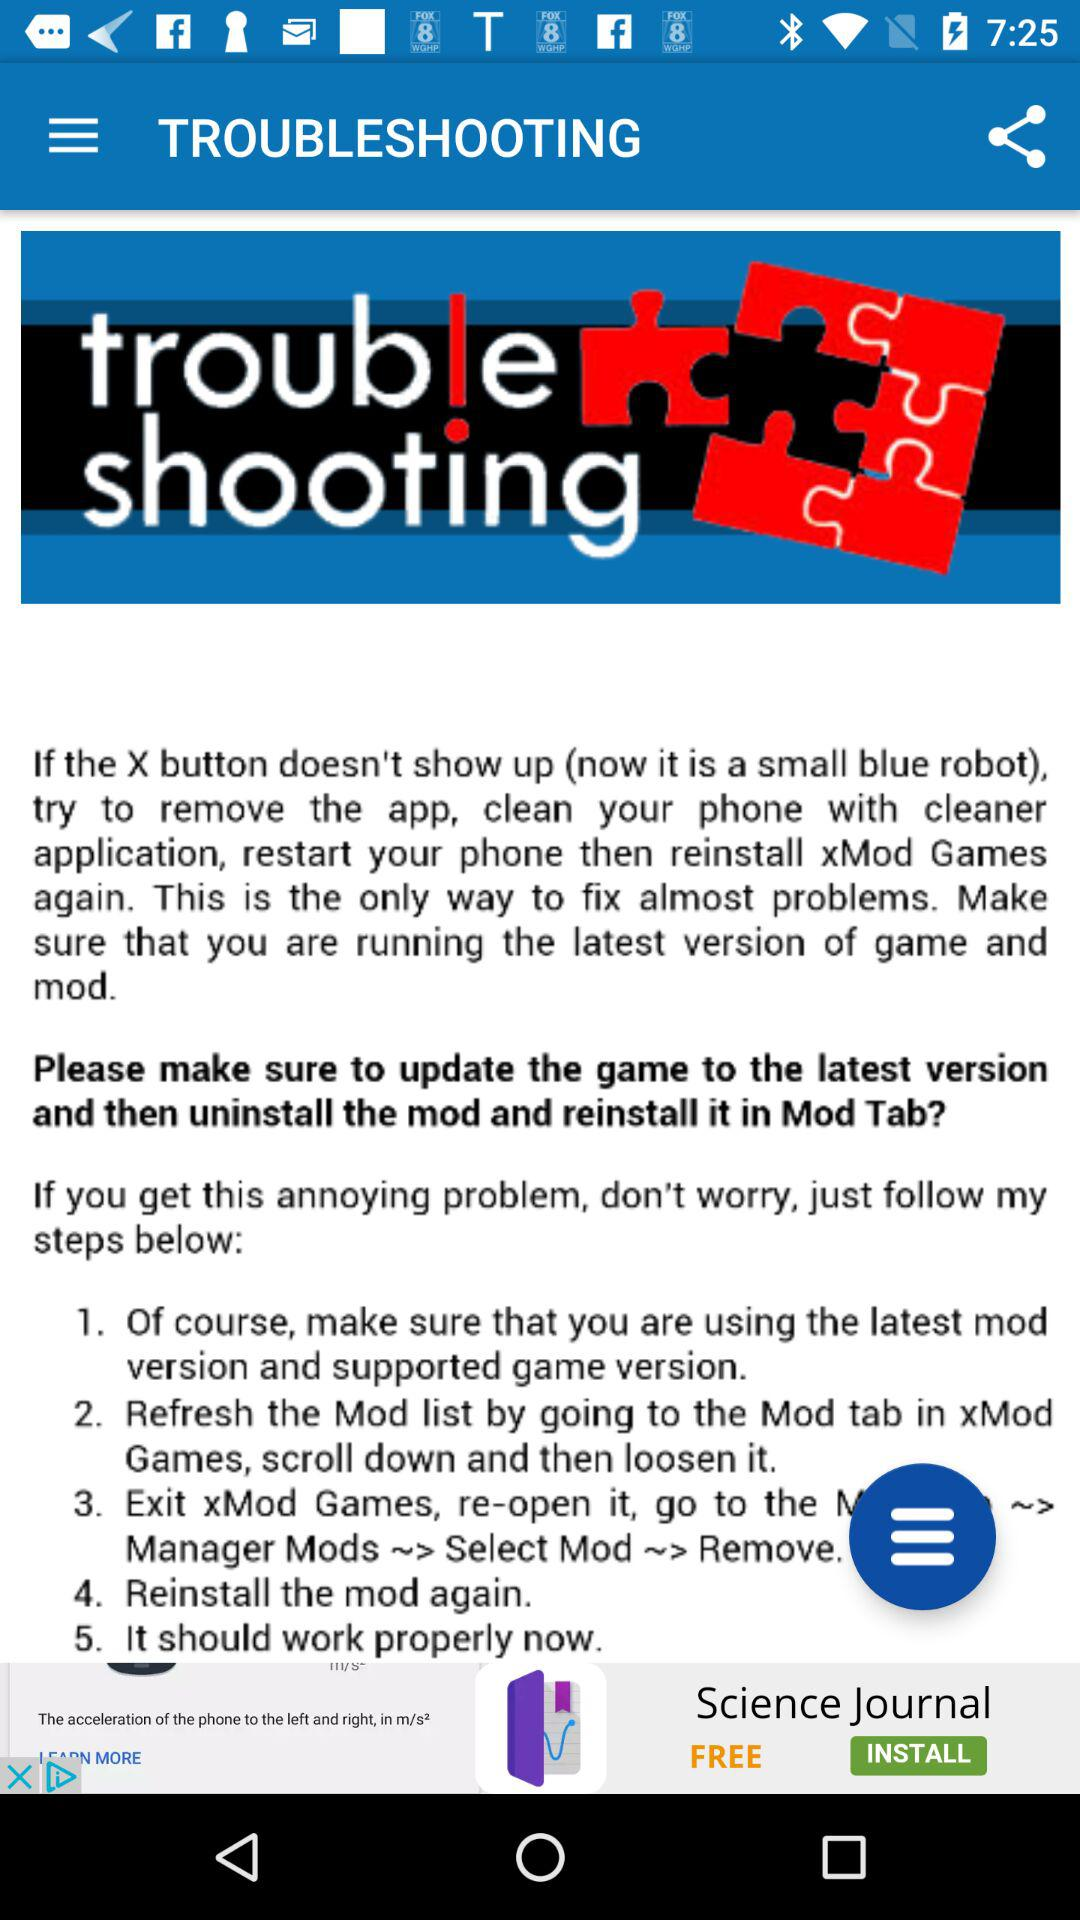How many steps are there in the troubleshooting guide?
Answer the question using a single word or phrase. 5 